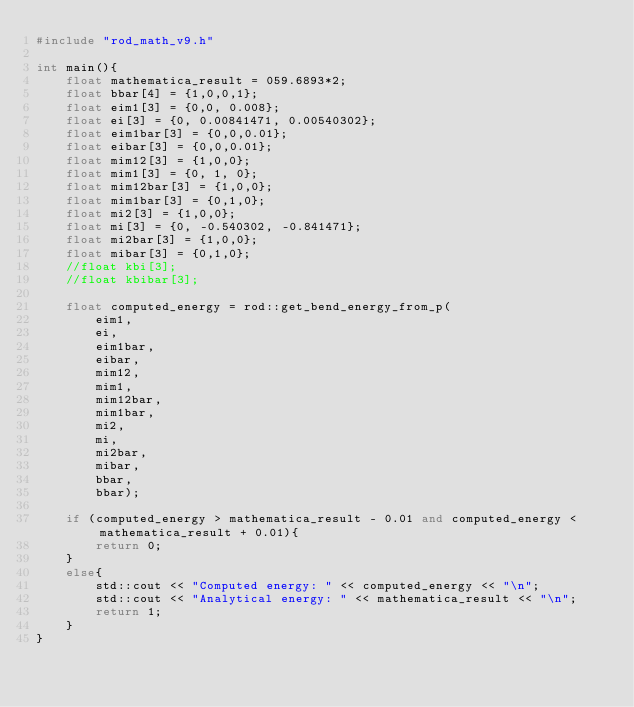Convert code to text. <code><loc_0><loc_0><loc_500><loc_500><_C++_>#include "rod_math_v9.h"

int main(){
    float mathematica_result = 059.6893*2;
    float bbar[4] = {1,0,0,1};
    float eim1[3] = {0,0, 0.008};
    float ei[3] = {0, 0.00841471, 0.00540302};
    float eim1bar[3] = {0,0,0.01};
    float eibar[3] = {0,0,0.01};
    float mim12[3] = {1,0,0};
    float mim1[3] = {0, 1, 0};
    float mim12bar[3] = {1,0,0};
    float mim1bar[3] = {0,1,0};
    float mi2[3] = {1,0,0};
    float mi[3] = {0, -0.540302, -0.841471};
    float mi2bar[3] = {1,0,0};
    float mibar[3] = {0,1,0};
    //float kbi[3];
    //float kbibar[3];
    
    float computed_energy = rod::get_bend_energy_from_p(
        eim1,
        ei,
        eim1bar,
        eibar,
        mim12,
        mim1,
        mim12bar,
        mim1bar,
        mi2,
        mi,
        mi2bar,
        mibar,
        bbar,
        bbar);
        
    if (computed_energy > mathematica_result - 0.01 and computed_energy < mathematica_result + 0.01){
        return 0;
    }
    else{
        std::cout << "Computed energy: " << computed_energy << "\n";
        std::cout << "Analytical energy: " << mathematica_result << "\n";
        return 1;
    }
}
</code> 